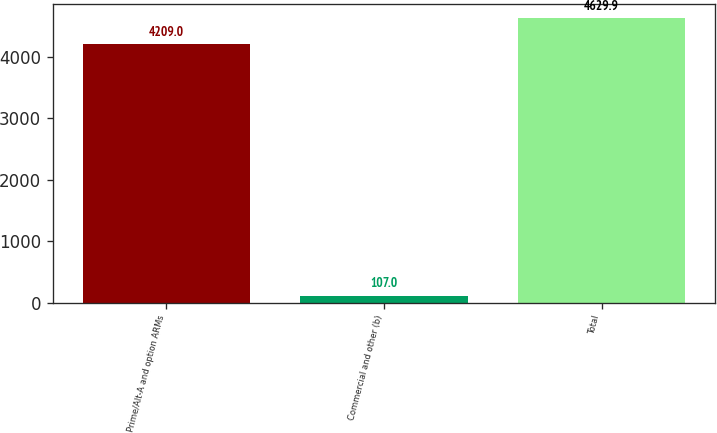<chart> <loc_0><loc_0><loc_500><loc_500><bar_chart><fcel>Prime/Alt-A and option ARMs<fcel>Commercial and other (b)<fcel>Total<nl><fcel>4209<fcel>107<fcel>4629.9<nl></chart> 